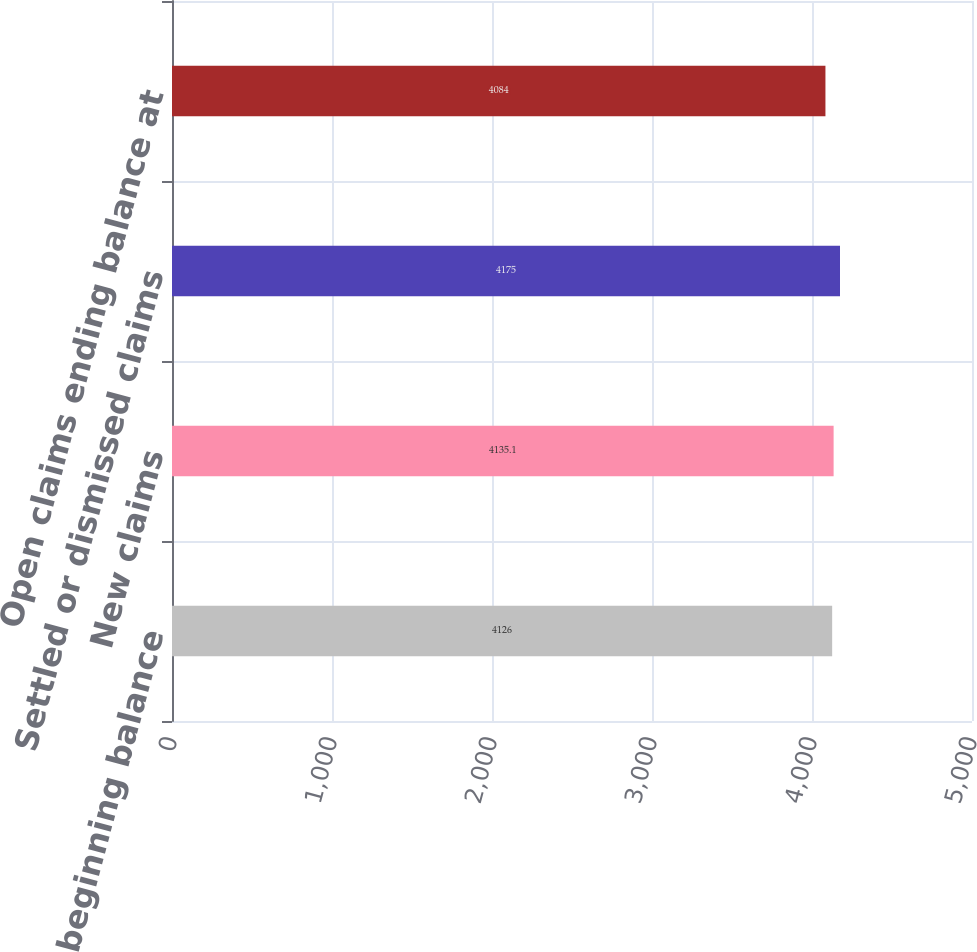Convert chart. <chart><loc_0><loc_0><loc_500><loc_500><bar_chart><fcel>Open claims beginning balance<fcel>New claims<fcel>Settled or dismissed claims<fcel>Open claims ending balance at<nl><fcel>4126<fcel>4135.1<fcel>4175<fcel>4084<nl></chart> 